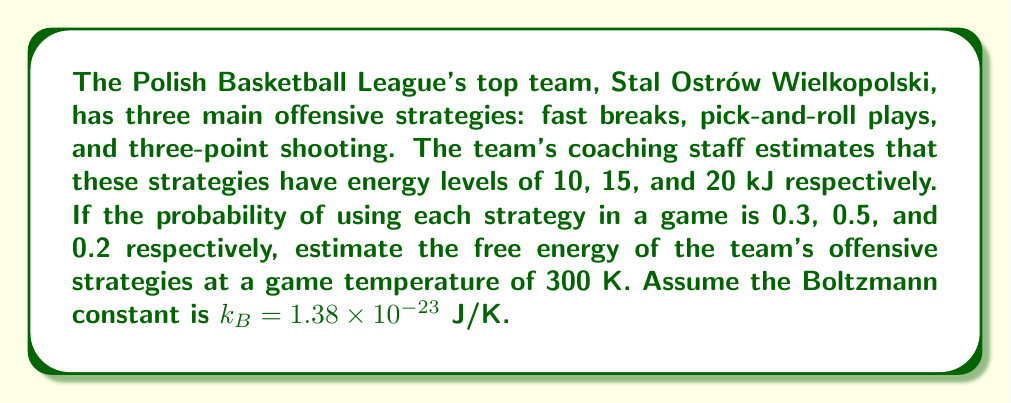Can you answer this question? To estimate the free energy of the team's offensive strategies, we'll use the formula for Helmholtz free energy:

$$F = U - TS$$

Where:
$F$ is the free energy
$U$ is the internal energy
$T$ is the temperature
$S$ is the entropy

Step 1: Calculate the internal energy $U$
The internal energy is the average energy of the system:
$$U = 0.3 \times 10 + 0.5 \times 15 + 0.2 \times 20 = 14.5 \text{ kJ}$$

Step 2: Calculate the entropy $S$
The entropy is given by the formula:
$$S = -k_B \sum_i p_i \ln p_i$$

$$S = -k_B [(0.3 \ln 0.3) + (0.5 \ln 0.5) + (0.2 \ln 0.2)]$$
$$S = -1.38 \times 10^{-23} \times (-1.0297) = 1.421 \times 10^{-23} \text{ J/K}$$

Step 3: Calculate the free energy $F$
$$F = U - TS$$
$$F = 14500 - 300 \times 1.421 \times 10^{-23}$$
$$F = 14500 - 4.263 \times 10^{-21}$$
$$F \approx 14500 \text{ J} = 14.5 \text{ kJ}$$

The difference between $U$ and $F$ is negligible due to the small value of $k_B$.
Answer: 14.5 kJ 